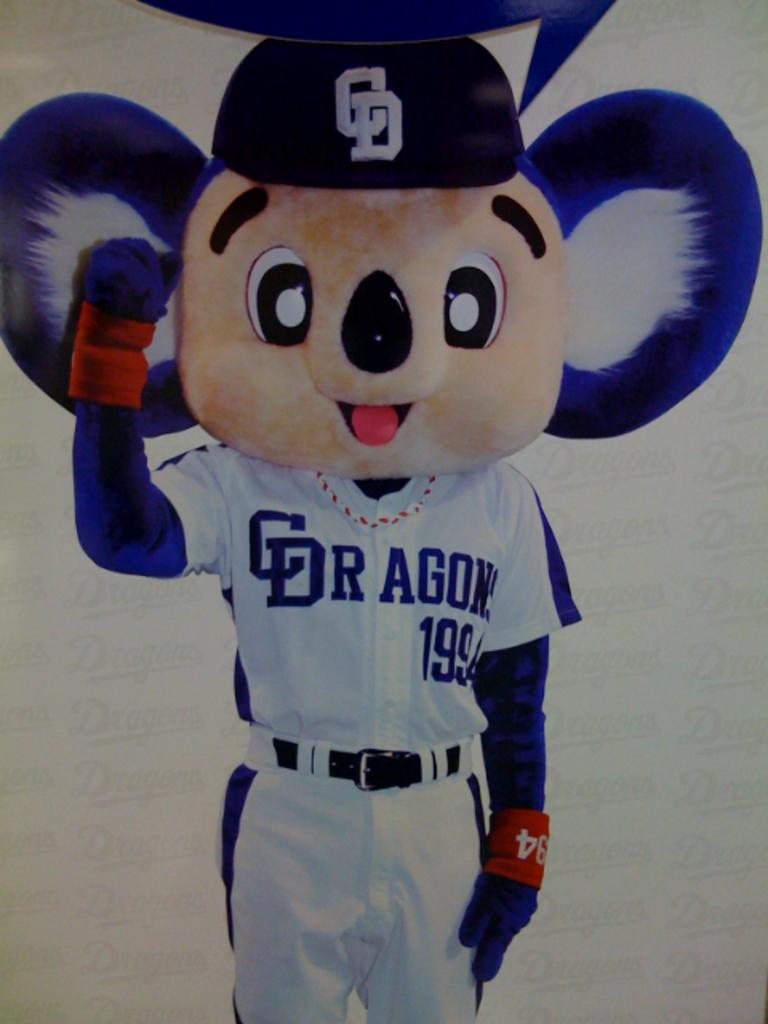<image>
Summarize the visual content of the image. The mascot for the Dragons team is doing a fist in the air. 